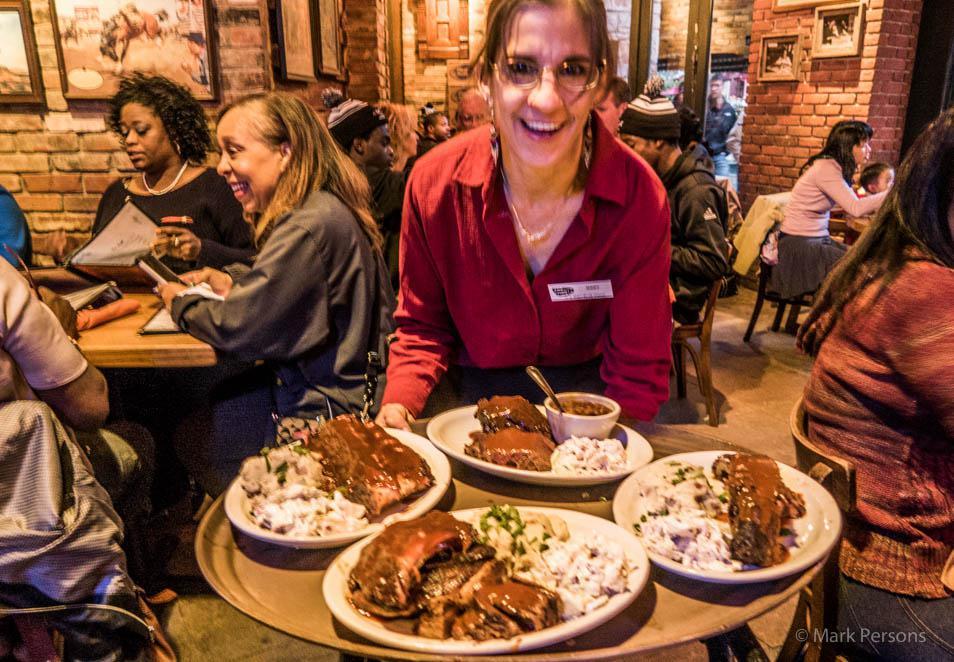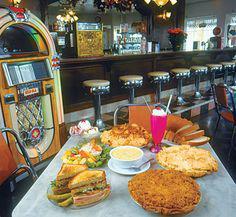The first image is the image on the left, the second image is the image on the right. Examine the images to the left and right. Is the description "The foreground of an image features someone with an extended arm holding up multiple white plates filled with food." accurate? Answer yes or no. Yes. The first image is the image on the left, the second image is the image on the right. For the images displayed, is the sentence "In at one image there is a server holding at least two white plates." factually correct? Answer yes or no. Yes. 